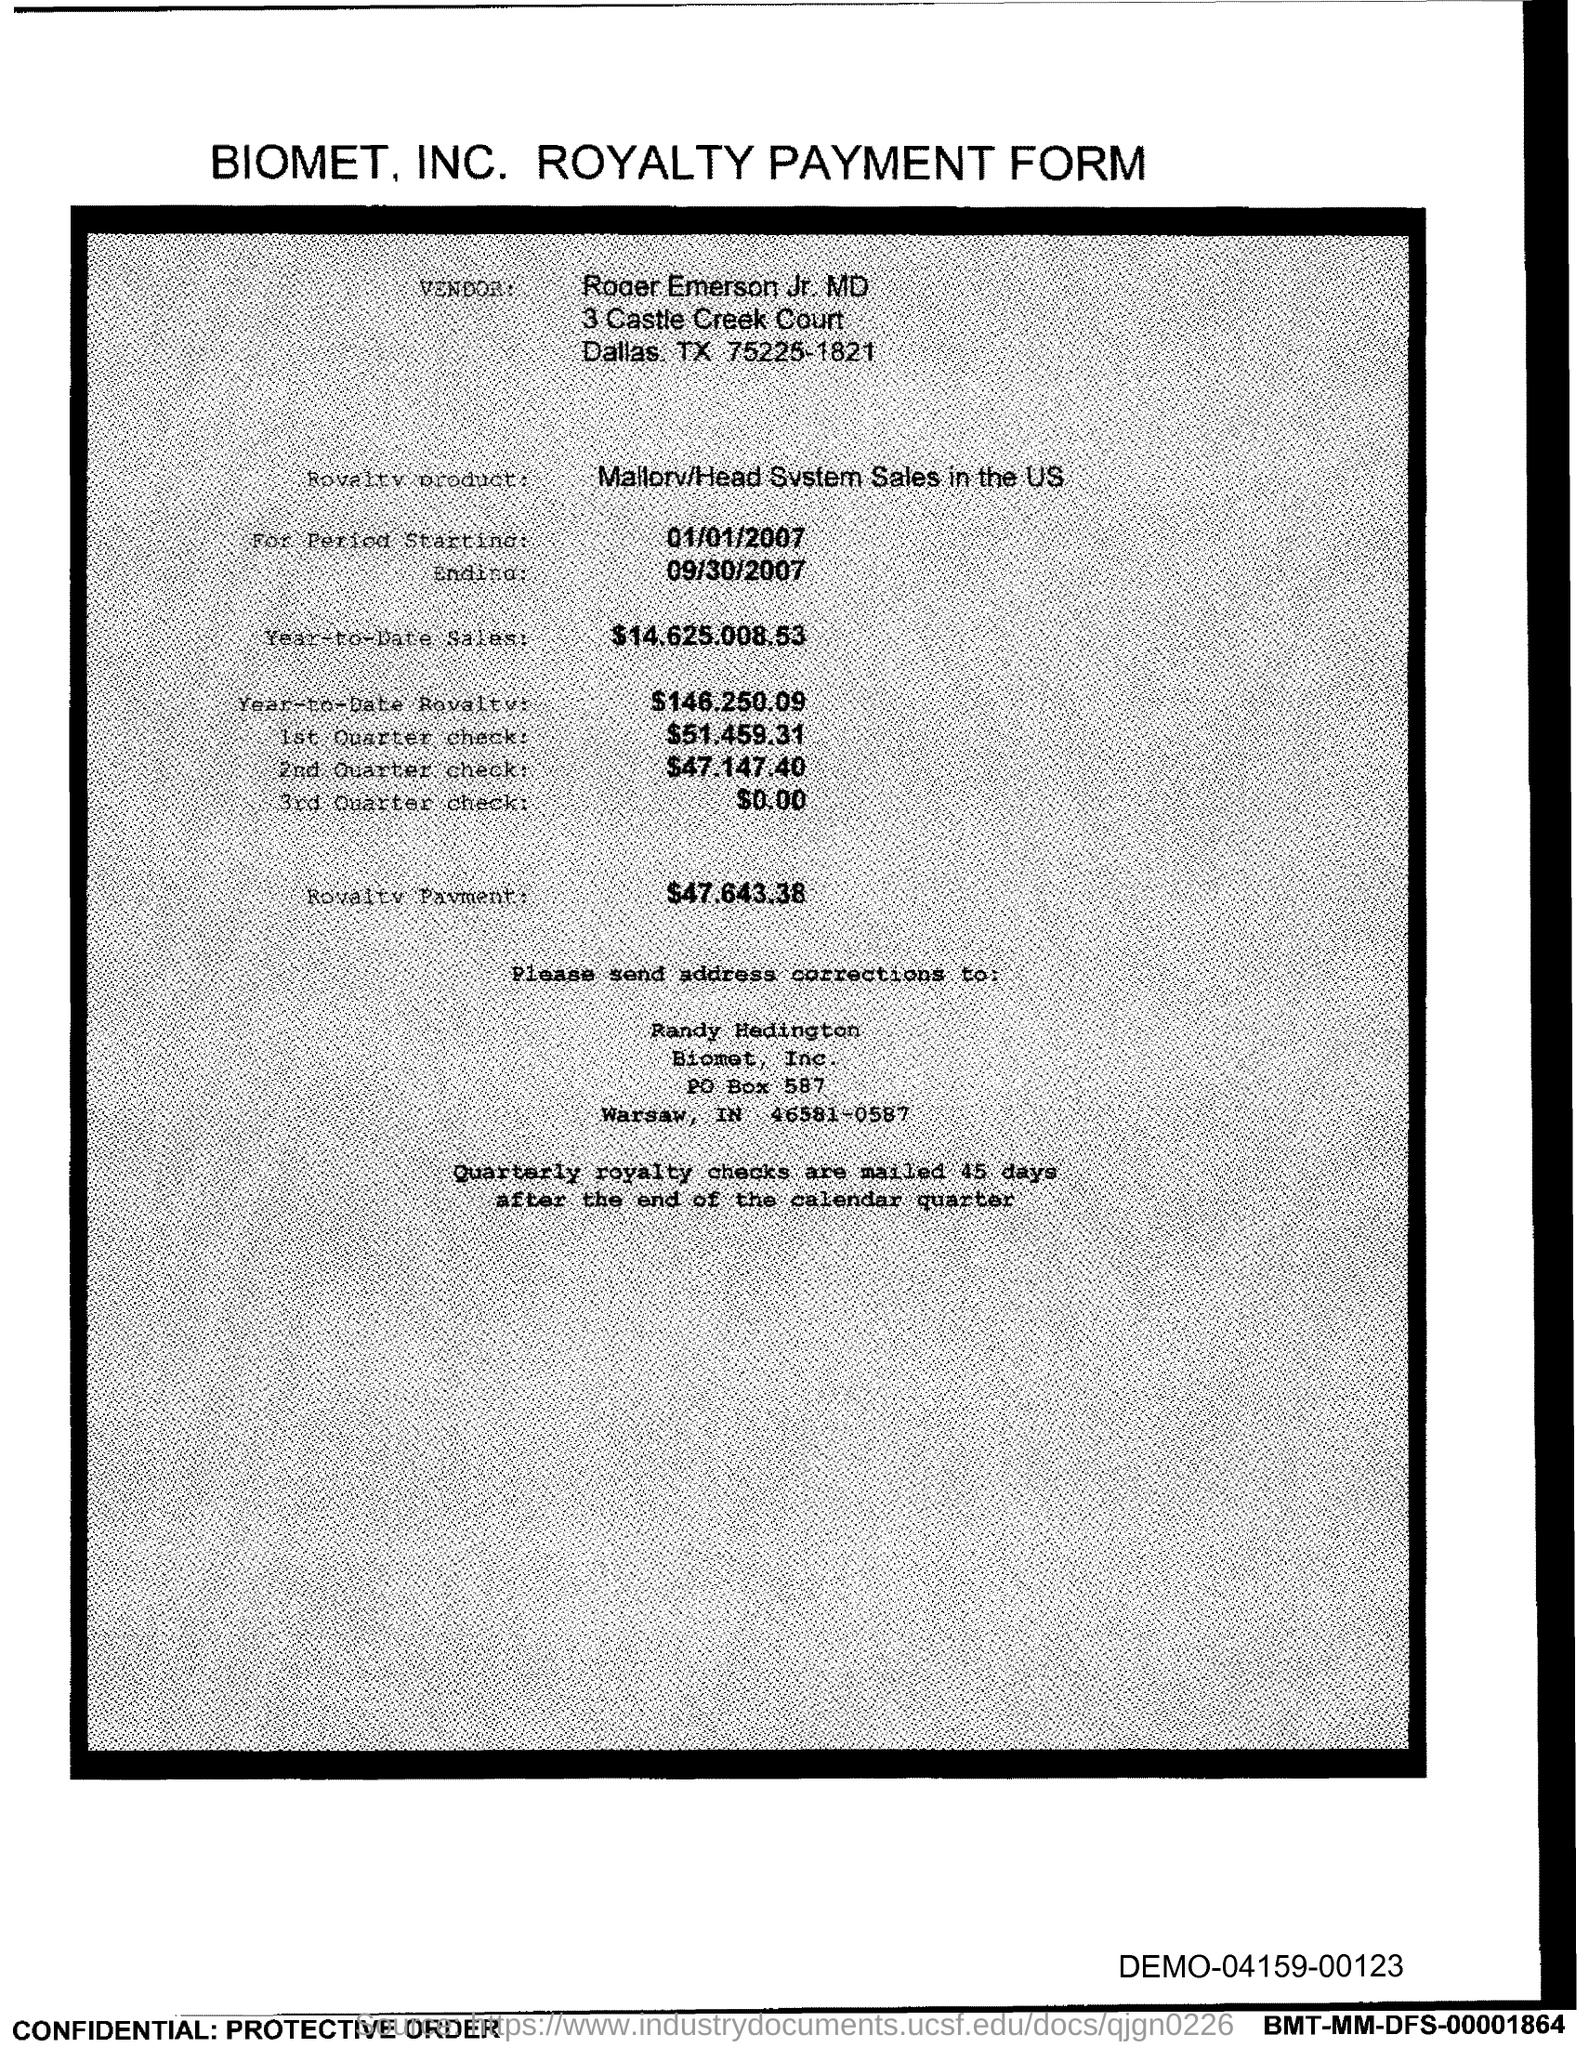What is the start date of the royalty period?
 01/01/2007 